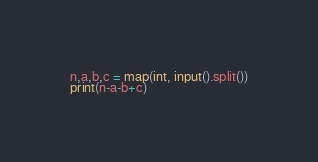<code> <loc_0><loc_0><loc_500><loc_500><_Python_>n,a,b,c = map(int, input().split())
print(n-a-b+c)
</code> 